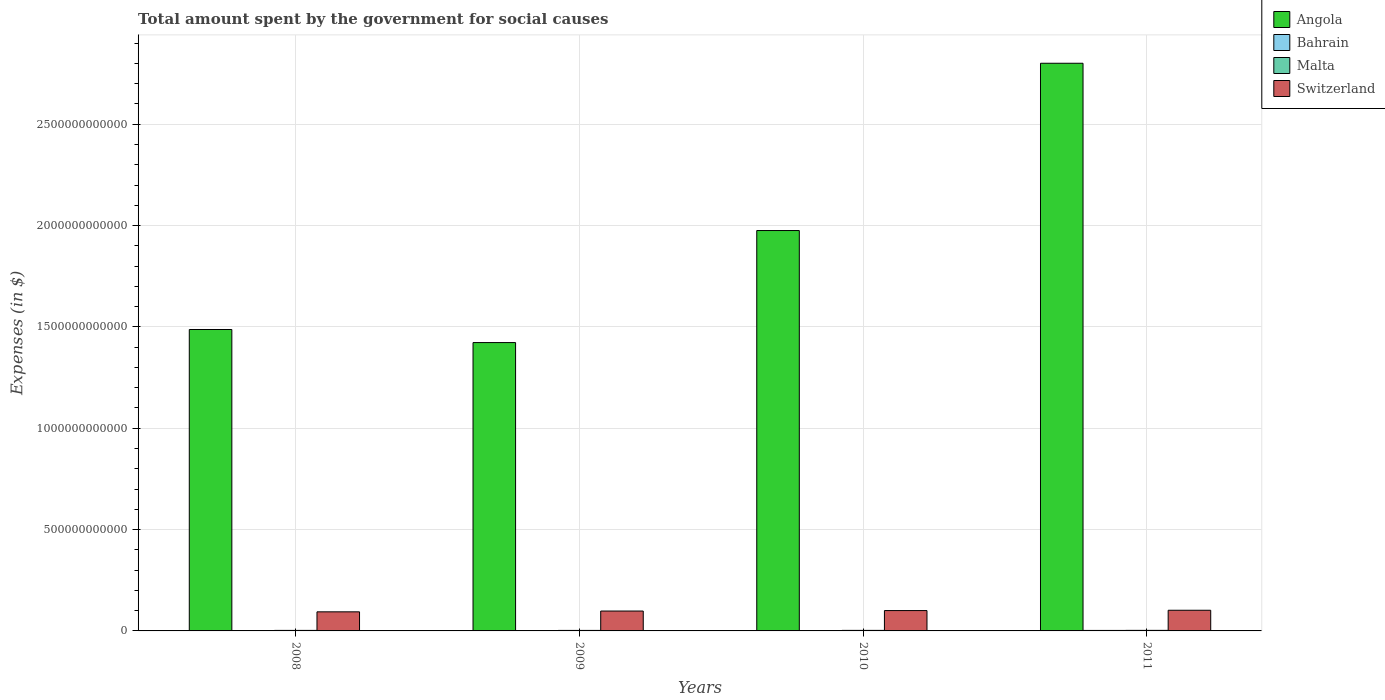Are the number of bars per tick equal to the number of legend labels?
Offer a very short reply. Yes. How many bars are there on the 1st tick from the left?
Your answer should be compact. 4. What is the label of the 4th group of bars from the left?
Ensure brevity in your answer.  2011. In how many cases, is the number of bars for a given year not equal to the number of legend labels?
Provide a short and direct response. 0. What is the amount spent for social causes by the government in Malta in 2011?
Your answer should be compact. 2.72e+09. Across all years, what is the maximum amount spent for social causes by the government in Bahrain?
Your answer should be compact. 2.43e+09. Across all years, what is the minimum amount spent for social causes by the government in Malta?
Provide a short and direct response. 2.53e+09. In which year was the amount spent for social causes by the government in Bahrain minimum?
Keep it short and to the point. 2008. What is the total amount spent for social causes by the government in Angola in the graph?
Offer a terse response. 7.69e+12. What is the difference between the amount spent for social causes by the government in Malta in 2008 and that in 2010?
Give a very brief answer. -1.17e+08. What is the difference between the amount spent for social causes by the government in Angola in 2011 and the amount spent for social causes by the government in Switzerland in 2010?
Ensure brevity in your answer.  2.70e+12. What is the average amount spent for social causes by the government in Switzerland per year?
Your answer should be very brief. 9.87e+1. In the year 2011, what is the difference between the amount spent for social causes by the government in Malta and amount spent for social causes by the government in Angola?
Give a very brief answer. -2.80e+12. In how many years, is the amount spent for social causes by the government in Angola greater than 1100000000000 $?
Make the answer very short. 4. What is the ratio of the amount spent for social causes by the government in Bahrain in 2008 to that in 2009?
Provide a short and direct response. 0.92. What is the difference between the highest and the second highest amount spent for social causes by the government in Angola?
Ensure brevity in your answer.  8.25e+11. What is the difference between the highest and the lowest amount spent for social causes by the government in Malta?
Provide a short and direct response. 1.93e+08. Is it the case that in every year, the sum of the amount spent for social causes by the government in Angola and amount spent for social causes by the government in Malta is greater than the sum of amount spent for social causes by the government in Switzerland and amount spent for social causes by the government in Bahrain?
Keep it short and to the point. No. What does the 4th bar from the left in 2008 represents?
Make the answer very short. Switzerland. What does the 4th bar from the right in 2009 represents?
Provide a succinct answer. Angola. Are all the bars in the graph horizontal?
Your answer should be compact. No. What is the difference between two consecutive major ticks on the Y-axis?
Your response must be concise. 5.00e+11. Are the values on the major ticks of Y-axis written in scientific E-notation?
Give a very brief answer. No. Does the graph contain any zero values?
Offer a terse response. No. Does the graph contain grids?
Offer a terse response. Yes. Where does the legend appear in the graph?
Make the answer very short. Top right. How are the legend labels stacked?
Offer a terse response. Vertical. What is the title of the graph?
Keep it short and to the point. Total amount spent by the government for social causes. What is the label or title of the Y-axis?
Give a very brief answer. Expenses (in $). What is the Expenses (in $) in Angola in 2008?
Make the answer very short. 1.49e+12. What is the Expenses (in $) of Bahrain in 2008?
Provide a short and direct response. 1.57e+09. What is the Expenses (in $) in Malta in 2008?
Offer a terse response. 2.54e+09. What is the Expenses (in $) in Switzerland in 2008?
Ensure brevity in your answer.  9.41e+1. What is the Expenses (in $) of Angola in 2009?
Offer a terse response. 1.42e+12. What is the Expenses (in $) in Bahrain in 2009?
Make the answer very short. 1.70e+09. What is the Expenses (in $) of Malta in 2009?
Provide a succinct answer. 2.53e+09. What is the Expenses (in $) in Switzerland in 2009?
Give a very brief answer. 9.81e+1. What is the Expenses (in $) in Angola in 2010?
Offer a very short reply. 1.98e+12. What is the Expenses (in $) in Bahrain in 2010?
Ensure brevity in your answer.  1.88e+09. What is the Expenses (in $) in Malta in 2010?
Offer a very short reply. 2.66e+09. What is the Expenses (in $) in Switzerland in 2010?
Your answer should be compact. 1.00e+11. What is the Expenses (in $) of Angola in 2011?
Make the answer very short. 2.80e+12. What is the Expenses (in $) in Bahrain in 2011?
Make the answer very short. 2.43e+09. What is the Expenses (in $) of Malta in 2011?
Offer a very short reply. 2.72e+09. What is the Expenses (in $) in Switzerland in 2011?
Offer a terse response. 1.02e+11. Across all years, what is the maximum Expenses (in $) in Angola?
Your answer should be very brief. 2.80e+12. Across all years, what is the maximum Expenses (in $) in Bahrain?
Offer a terse response. 2.43e+09. Across all years, what is the maximum Expenses (in $) of Malta?
Provide a succinct answer. 2.72e+09. Across all years, what is the maximum Expenses (in $) of Switzerland?
Keep it short and to the point. 1.02e+11. Across all years, what is the minimum Expenses (in $) in Angola?
Your answer should be compact. 1.42e+12. Across all years, what is the minimum Expenses (in $) in Bahrain?
Keep it short and to the point. 1.57e+09. Across all years, what is the minimum Expenses (in $) of Malta?
Keep it short and to the point. 2.53e+09. Across all years, what is the minimum Expenses (in $) in Switzerland?
Make the answer very short. 9.41e+1. What is the total Expenses (in $) in Angola in the graph?
Offer a very short reply. 7.69e+12. What is the total Expenses (in $) in Bahrain in the graph?
Give a very brief answer. 7.59e+09. What is the total Expenses (in $) in Malta in the graph?
Your answer should be compact. 1.04e+1. What is the total Expenses (in $) in Switzerland in the graph?
Ensure brevity in your answer.  3.95e+11. What is the difference between the Expenses (in $) of Angola in 2008 and that in 2009?
Ensure brevity in your answer.  6.45e+1. What is the difference between the Expenses (in $) of Bahrain in 2008 and that in 2009?
Offer a terse response. -1.37e+08. What is the difference between the Expenses (in $) in Malta in 2008 and that in 2009?
Offer a very short reply. 1.65e+07. What is the difference between the Expenses (in $) of Switzerland in 2008 and that in 2009?
Keep it short and to the point. -3.96e+09. What is the difference between the Expenses (in $) of Angola in 2008 and that in 2010?
Your response must be concise. -4.88e+11. What is the difference between the Expenses (in $) in Bahrain in 2008 and that in 2010?
Offer a terse response. -3.14e+08. What is the difference between the Expenses (in $) in Malta in 2008 and that in 2010?
Offer a very short reply. -1.17e+08. What is the difference between the Expenses (in $) in Switzerland in 2008 and that in 2010?
Offer a terse response. -6.28e+09. What is the difference between the Expenses (in $) of Angola in 2008 and that in 2011?
Ensure brevity in your answer.  -1.31e+12. What is the difference between the Expenses (in $) in Bahrain in 2008 and that in 2011?
Offer a very short reply. -8.67e+08. What is the difference between the Expenses (in $) of Malta in 2008 and that in 2011?
Give a very brief answer. -1.77e+08. What is the difference between the Expenses (in $) in Switzerland in 2008 and that in 2011?
Give a very brief answer. -7.85e+09. What is the difference between the Expenses (in $) of Angola in 2009 and that in 2010?
Offer a terse response. -5.53e+11. What is the difference between the Expenses (in $) in Bahrain in 2009 and that in 2010?
Provide a short and direct response. -1.78e+08. What is the difference between the Expenses (in $) in Malta in 2009 and that in 2010?
Keep it short and to the point. -1.33e+08. What is the difference between the Expenses (in $) of Switzerland in 2009 and that in 2010?
Offer a terse response. -2.31e+09. What is the difference between the Expenses (in $) in Angola in 2009 and that in 2011?
Your answer should be very brief. -1.38e+12. What is the difference between the Expenses (in $) in Bahrain in 2009 and that in 2011?
Your answer should be compact. -7.30e+08. What is the difference between the Expenses (in $) of Malta in 2009 and that in 2011?
Provide a succinct answer. -1.93e+08. What is the difference between the Expenses (in $) of Switzerland in 2009 and that in 2011?
Ensure brevity in your answer.  -3.89e+09. What is the difference between the Expenses (in $) in Angola in 2010 and that in 2011?
Your answer should be compact. -8.25e+11. What is the difference between the Expenses (in $) in Bahrain in 2010 and that in 2011?
Offer a very short reply. -5.53e+08. What is the difference between the Expenses (in $) of Malta in 2010 and that in 2011?
Give a very brief answer. -5.97e+07. What is the difference between the Expenses (in $) in Switzerland in 2010 and that in 2011?
Offer a very short reply. -1.58e+09. What is the difference between the Expenses (in $) of Angola in 2008 and the Expenses (in $) of Bahrain in 2009?
Make the answer very short. 1.49e+12. What is the difference between the Expenses (in $) of Angola in 2008 and the Expenses (in $) of Malta in 2009?
Make the answer very short. 1.48e+12. What is the difference between the Expenses (in $) in Angola in 2008 and the Expenses (in $) in Switzerland in 2009?
Offer a terse response. 1.39e+12. What is the difference between the Expenses (in $) in Bahrain in 2008 and the Expenses (in $) in Malta in 2009?
Provide a short and direct response. -9.57e+08. What is the difference between the Expenses (in $) in Bahrain in 2008 and the Expenses (in $) in Switzerland in 2009?
Your answer should be very brief. -9.65e+1. What is the difference between the Expenses (in $) in Malta in 2008 and the Expenses (in $) in Switzerland in 2009?
Make the answer very short. -9.56e+1. What is the difference between the Expenses (in $) of Angola in 2008 and the Expenses (in $) of Bahrain in 2010?
Offer a terse response. 1.49e+12. What is the difference between the Expenses (in $) in Angola in 2008 and the Expenses (in $) in Malta in 2010?
Provide a short and direct response. 1.48e+12. What is the difference between the Expenses (in $) in Angola in 2008 and the Expenses (in $) in Switzerland in 2010?
Your answer should be very brief. 1.39e+12. What is the difference between the Expenses (in $) of Bahrain in 2008 and the Expenses (in $) of Malta in 2010?
Provide a short and direct response. -1.09e+09. What is the difference between the Expenses (in $) of Bahrain in 2008 and the Expenses (in $) of Switzerland in 2010?
Offer a very short reply. -9.88e+1. What is the difference between the Expenses (in $) of Malta in 2008 and the Expenses (in $) of Switzerland in 2010?
Offer a terse response. -9.79e+1. What is the difference between the Expenses (in $) in Angola in 2008 and the Expenses (in $) in Bahrain in 2011?
Ensure brevity in your answer.  1.48e+12. What is the difference between the Expenses (in $) in Angola in 2008 and the Expenses (in $) in Malta in 2011?
Make the answer very short. 1.48e+12. What is the difference between the Expenses (in $) of Angola in 2008 and the Expenses (in $) of Switzerland in 2011?
Your answer should be compact. 1.39e+12. What is the difference between the Expenses (in $) in Bahrain in 2008 and the Expenses (in $) in Malta in 2011?
Offer a very short reply. -1.15e+09. What is the difference between the Expenses (in $) of Bahrain in 2008 and the Expenses (in $) of Switzerland in 2011?
Your answer should be compact. -1.00e+11. What is the difference between the Expenses (in $) of Malta in 2008 and the Expenses (in $) of Switzerland in 2011?
Make the answer very short. -9.94e+1. What is the difference between the Expenses (in $) in Angola in 2009 and the Expenses (in $) in Bahrain in 2010?
Provide a short and direct response. 1.42e+12. What is the difference between the Expenses (in $) of Angola in 2009 and the Expenses (in $) of Malta in 2010?
Your answer should be compact. 1.42e+12. What is the difference between the Expenses (in $) of Angola in 2009 and the Expenses (in $) of Switzerland in 2010?
Make the answer very short. 1.32e+12. What is the difference between the Expenses (in $) of Bahrain in 2009 and the Expenses (in $) of Malta in 2010?
Offer a terse response. -9.54e+08. What is the difference between the Expenses (in $) of Bahrain in 2009 and the Expenses (in $) of Switzerland in 2010?
Give a very brief answer. -9.87e+1. What is the difference between the Expenses (in $) in Malta in 2009 and the Expenses (in $) in Switzerland in 2010?
Give a very brief answer. -9.79e+1. What is the difference between the Expenses (in $) in Angola in 2009 and the Expenses (in $) in Bahrain in 2011?
Make the answer very short. 1.42e+12. What is the difference between the Expenses (in $) of Angola in 2009 and the Expenses (in $) of Malta in 2011?
Your response must be concise. 1.42e+12. What is the difference between the Expenses (in $) in Angola in 2009 and the Expenses (in $) in Switzerland in 2011?
Provide a succinct answer. 1.32e+12. What is the difference between the Expenses (in $) of Bahrain in 2009 and the Expenses (in $) of Malta in 2011?
Give a very brief answer. -1.01e+09. What is the difference between the Expenses (in $) of Bahrain in 2009 and the Expenses (in $) of Switzerland in 2011?
Your answer should be very brief. -1.00e+11. What is the difference between the Expenses (in $) in Malta in 2009 and the Expenses (in $) in Switzerland in 2011?
Provide a succinct answer. -9.95e+1. What is the difference between the Expenses (in $) of Angola in 2010 and the Expenses (in $) of Bahrain in 2011?
Ensure brevity in your answer.  1.97e+12. What is the difference between the Expenses (in $) in Angola in 2010 and the Expenses (in $) in Malta in 2011?
Your answer should be compact. 1.97e+12. What is the difference between the Expenses (in $) of Angola in 2010 and the Expenses (in $) of Switzerland in 2011?
Your answer should be compact. 1.87e+12. What is the difference between the Expenses (in $) of Bahrain in 2010 and the Expenses (in $) of Malta in 2011?
Make the answer very short. -8.36e+08. What is the difference between the Expenses (in $) in Bahrain in 2010 and the Expenses (in $) in Switzerland in 2011?
Provide a succinct answer. -1.00e+11. What is the difference between the Expenses (in $) in Malta in 2010 and the Expenses (in $) in Switzerland in 2011?
Provide a succinct answer. -9.93e+1. What is the average Expenses (in $) of Angola per year?
Ensure brevity in your answer.  1.92e+12. What is the average Expenses (in $) of Bahrain per year?
Your answer should be compact. 1.90e+09. What is the average Expenses (in $) in Malta per year?
Provide a succinct answer. 2.61e+09. What is the average Expenses (in $) in Switzerland per year?
Make the answer very short. 9.87e+1. In the year 2008, what is the difference between the Expenses (in $) of Angola and Expenses (in $) of Bahrain?
Offer a terse response. 1.49e+12. In the year 2008, what is the difference between the Expenses (in $) of Angola and Expenses (in $) of Malta?
Your answer should be compact. 1.48e+12. In the year 2008, what is the difference between the Expenses (in $) of Angola and Expenses (in $) of Switzerland?
Offer a very short reply. 1.39e+12. In the year 2008, what is the difference between the Expenses (in $) in Bahrain and Expenses (in $) in Malta?
Offer a terse response. -9.74e+08. In the year 2008, what is the difference between the Expenses (in $) of Bahrain and Expenses (in $) of Switzerland?
Provide a succinct answer. -9.26e+1. In the year 2008, what is the difference between the Expenses (in $) of Malta and Expenses (in $) of Switzerland?
Offer a very short reply. -9.16e+1. In the year 2009, what is the difference between the Expenses (in $) in Angola and Expenses (in $) in Bahrain?
Ensure brevity in your answer.  1.42e+12. In the year 2009, what is the difference between the Expenses (in $) in Angola and Expenses (in $) in Malta?
Your answer should be very brief. 1.42e+12. In the year 2009, what is the difference between the Expenses (in $) in Angola and Expenses (in $) in Switzerland?
Keep it short and to the point. 1.32e+12. In the year 2009, what is the difference between the Expenses (in $) in Bahrain and Expenses (in $) in Malta?
Provide a short and direct response. -8.21e+08. In the year 2009, what is the difference between the Expenses (in $) in Bahrain and Expenses (in $) in Switzerland?
Offer a terse response. -9.64e+1. In the year 2009, what is the difference between the Expenses (in $) of Malta and Expenses (in $) of Switzerland?
Offer a terse response. -9.56e+1. In the year 2010, what is the difference between the Expenses (in $) of Angola and Expenses (in $) of Bahrain?
Keep it short and to the point. 1.97e+12. In the year 2010, what is the difference between the Expenses (in $) in Angola and Expenses (in $) in Malta?
Your answer should be very brief. 1.97e+12. In the year 2010, what is the difference between the Expenses (in $) in Angola and Expenses (in $) in Switzerland?
Make the answer very short. 1.87e+12. In the year 2010, what is the difference between the Expenses (in $) in Bahrain and Expenses (in $) in Malta?
Offer a terse response. -7.76e+08. In the year 2010, what is the difference between the Expenses (in $) in Bahrain and Expenses (in $) in Switzerland?
Make the answer very short. -9.85e+1. In the year 2010, what is the difference between the Expenses (in $) in Malta and Expenses (in $) in Switzerland?
Provide a short and direct response. -9.78e+1. In the year 2011, what is the difference between the Expenses (in $) in Angola and Expenses (in $) in Bahrain?
Your response must be concise. 2.80e+12. In the year 2011, what is the difference between the Expenses (in $) of Angola and Expenses (in $) of Malta?
Give a very brief answer. 2.80e+12. In the year 2011, what is the difference between the Expenses (in $) of Angola and Expenses (in $) of Switzerland?
Keep it short and to the point. 2.70e+12. In the year 2011, what is the difference between the Expenses (in $) of Bahrain and Expenses (in $) of Malta?
Offer a terse response. -2.83e+08. In the year 2011, what is the difference between the Expenses (in $) in Bahrain and Expenses (in $) in Switzerland?
Provide a short and direct response. -9.96e+1. In the year 2011, what is the difference between the Expenses (in $) of Malta and Expenses (in $) of Switzerland?
Provide a succinct answer. -9.93e+1. What is the ratio of the Expenses (in $) in Angola in 2008 to that in 2009?
Provide a succinct answer. 1.05. What is the ratio of the Expenses (in $) of Bahrain in 2008 to that in 2009?
Make the answer very short. 0.92. What is the ratio of the Expenses (in $) of Switzerland in 2008 to that in 2009?
Offer a terse response. 0.96. What is the ratio of the Expenses (in $) of Angola in 2008 to that in 2010?
Make the answer very short. 0.75. What is the ratio of the Expenses (in $) of Bahrain in 2008 to that in 2010?
Give a very brief answer. 0.83. What is the ratio of the Expenses (in $) in Malta in 2008 to that in 2010?
Your answer should be very brief. 0.96. What is the ratio of the Expenses (in $) of Switzerland in 2008 to that in 2010?
Ensure brevity in your answer.  0.94. What is the ratio of the Expenses (in $) in Angola in 2008 to that in 2011?
Ensure brevity in your answer.  0.53. What is the ratio of the Expenses (in $) in Bahrain in 2008 to that in 2011?
Offer a very short reply. 0.64. What is the ratio of the Expenses (in $) in Malta in 2008 to that in 2011?
Make the answer very short. 0.94. What is the ratio of the Expenses (in $) in Switzerland in 2008 to that in 2011?
Offer a terse response. 0.92. What is the ratio of the Expenses (in $) in Angola in 2009 to that in 2010?
Give a very brief answer. 0.72. What is the ratio of the Expenses (in $) of Bahrain in 2009 to that in 2010?
Keep it short and to the point. 0.91. What is the ratio of the Expenses (in $) in Malta in 2009 to that in 2010?
Give a very brief answer. 0.95. What is the ratio of the Expenses (in $) of Angola in 2009 to that in 2011?
Offer a very short reply. 0.51. What is the ratio of the Expenses (in $) in Bahrain in 2009 to that in 2011?
Keep it short and to the point. 0.7. What is the ratio of the Expenses (in $) of Malta in 2009 to that in 2011?
Give a very brief answer. 0.93. What is the ratio of the Expenses (in $) of Switzerland in 2009 to that in 2011?
Offer a very short reply. 0.96. What is the ratio of the Expenses (in $) of Angola in 2010 to that in 2011?
Keep it short and to the point. 0.71. What is the ratio of the Expenses (in $) in Bahrain in 2010 to that in 2011?
Provide a succinct answer. 0.77. What is the ratio of the Expenses (in $) of Malta in 2010 to that in 2011?
Your answer should be compact. 0.98. What is the ratio of the Expenses (in $) in Switzerland in 2010 to that in 2011?
Your response must be concise. 0.98. What is the difference between the highest and the second highest Expenses (in $) of Angola?
Give a very brief answer. 8.25e+11. What is the difference between the highest and the second highest Expenses (in $) in Bahrain?
Your response must be concise. 5.53e+08. What is the difference between the highest and the second highest Expenses (in $) in Malta?
Offer a very short reply. 5.97e+07. What is the difference between the highest and the second highest Expenses (in $) of Switzerland?
Give a very brief answer. 1.58e+09. What is the difference between the highest and the lowest Expenses (in $) of Angola?
Make the answer very short. 1.38e+12. What is the difference between the highest and the lowest Expenses (in $) of Bahrain?
Your response must be concise. 8.67e+08. What is the difference between the highest and the lowest Expenses (in $) of Malta?
Provide a succinct answer. 1.93e+08. What is the difference between the highest and the lowest Expenses (in $) of Switzerland?
Offer a terse response. 7.85e+09. 